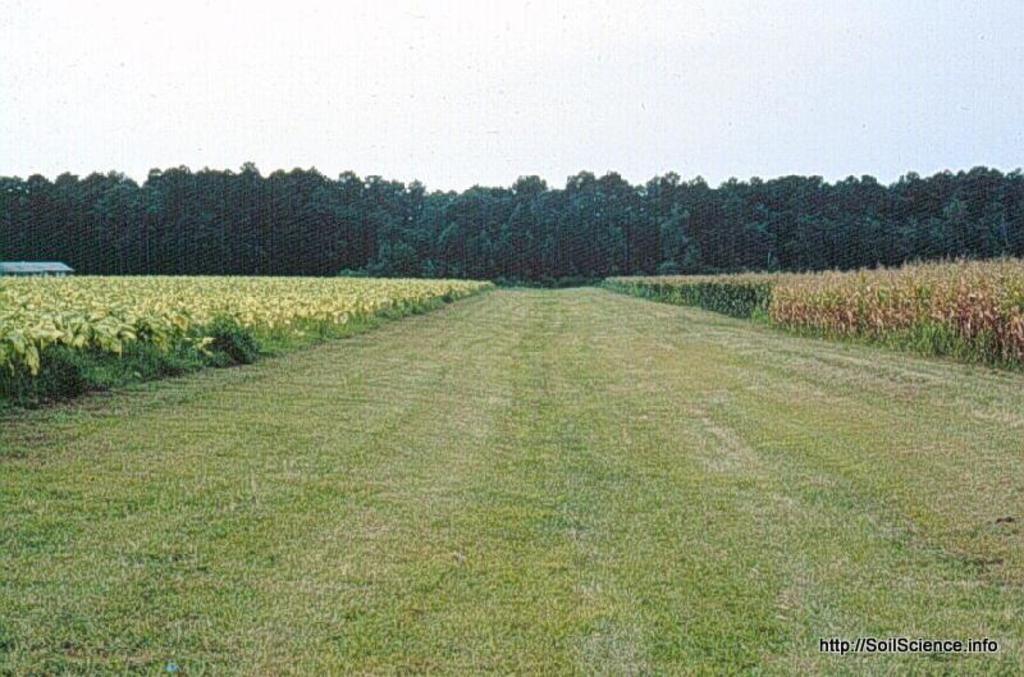In one or two sentences, can you explain what this image depicts? In this picture there is a greenery ground and there are few plants on either sides of it and there are trees in the background and there is something written in the right bottom corner. 